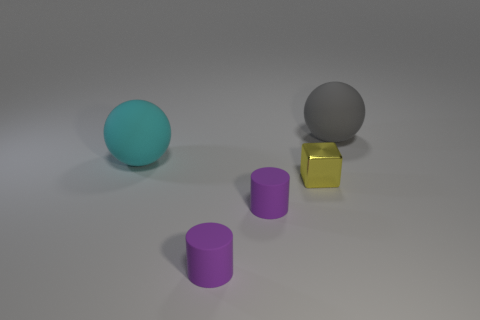Add 3 tiny purple matte cylinders. How many objects exist? 8 Subtract all blocks. How many objects are left? 4 Add 3 purple matte cylinders. How many purple matte cylinders are left? 5 Add 3 blocks. How many blocks exist? 4 Subtract 0 brown spheres. How many objects are left? 5 Subtract all tiny blocks. Subtract all large cyan objects. How many objects are left? 3 